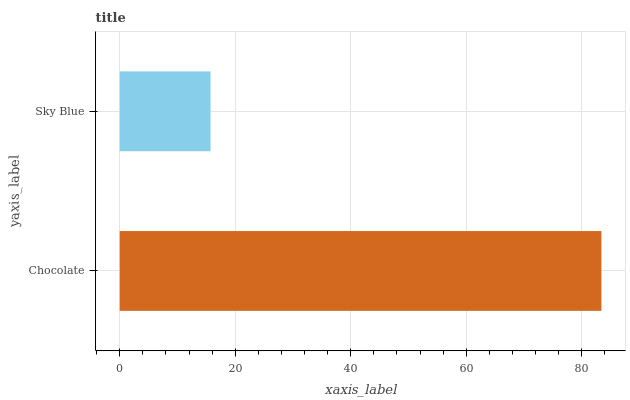Is Sky Blue the minimum?
Answer yes or no. Yes. Is Chocolate the maximum?
Answer yes or no. Yes. Is Sky Blue the maximum?
Answer yes or no. No. Is Chocolate greater than Sky Blue?
Answer yes or no. Yes. Is Sky Blue less than Chocolate?
Answer yes or no. Yes. Is Sky Blue greater than Chocolate?
Answer yes or no. No. Is Chocolate less than Sky Blue?
Answer yes or no. No. Is Chocolate the high median?
Answer yes or no. Yes. Is Sky Blue the low median?
Answer yes or no. Yes. Is Sky Blue the high median?
Answer yes or no. No. Is Chocolate the low median?
Answer yes or no. No. 